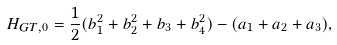<formula> <loc_0><loc_0><loc_500><loc_500>H _ { G T , 0 } = \frac { 1 } { 2 } ( b _ { 1 } ^ { 2 } + b _ { 2 } ^ { 2 } + b _ { 3 } + b _ { 4 } ^ { 2 } ) - ( a _ { 1 } + a _ { 2 } + a _ { 3 } ) ,</formula> 